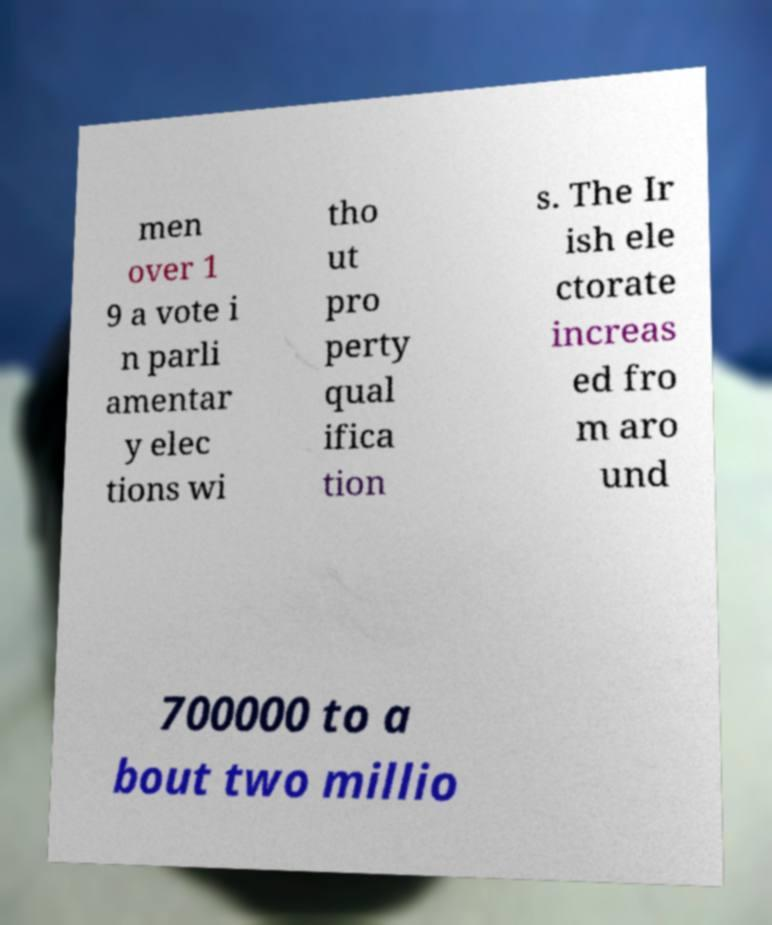Could you assist in decoding the text presented in this image and type it out clearly? men over 1 9 a vote i n parli amentar y elec tions wi tho ut pro perty qual ifica tion s. The Ir ish ele ctorate increas ed fro m aro und 700000 to a bout two millio 